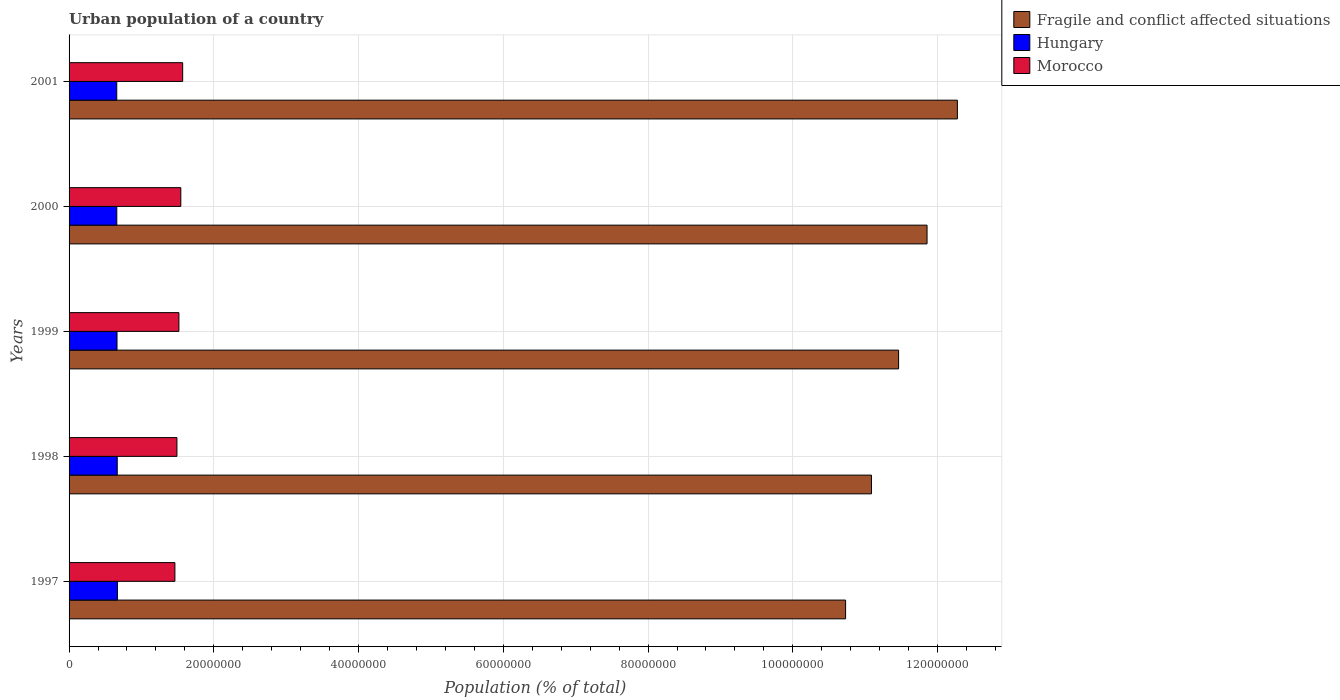How many different coloured bars are there?
Offer a terse response. 3. How many groups of bars are there?
Give a very brief answer. 5. Are the number of bars per tick equal to the number of legend labels?
Give a very brief answer. Yes. How many bars are there on the 5th tick from the top?
Ensure brevity in your answer.  3. How many bars are there on the 3rd tick from the bottom?
Your response must be concise. 3. In how many cases, is the number of bars for a given year not equal to the number of legend labels?
Ensure brevity in your answer.  0. What is the urban population in Hungary in 2000?
Your answer should be compact. 6.59e+06. Across all years, what is the maximum urban population in Fragile and conflict affected situations?
Offer a very short reply. 1.23e+08. Across all years, what is the minimum urban population in Hungary?
Make the answer very short. 6.59e+06. What is the total urban population in Hungary in the graph?
Provide a short and direct response. 3.31e+07. What is the difference between the urban population in Fragile and conflict affected situations in 1998 and that in 2000?
Offer a terse response. -7.68e+06. What is the difference between the urban population in Morocco in 1998 and the urban population in Hungary in 2001?
Offer a terse response. 8.32e+06. What is the average urban population in Morocco per year?
Provide a succinct answer. 1.52e+07. In the year 1997, what is the difference between the urban population in Morocco and urban population in Fragile and conflict affected situations?
Your answer should be compact. -9.27e+07. What is the ratio of the urban population in Morocco in 1997 to that in 1999?
Your answer should be very brief. 0.96. Is the urban population in Hungary in 1998 less than that in 1999?
Your response must be concise. No. Is the difference between the urban population in Morocco in 1999 and 2000 greater than the difference between the urban population in Fragile and conflict affected situations in 1999 and 2000?
Give a very brief answer. Yes. What is the difference between the highest and the second highest urban population in Hungary?
Keep it short and to the point. 2.86e+04. What is the difference between the highest and the lowest urban population in Morocco?
Ensure brevity in your answer.  1.07e+06. In how many years, is the urban population in Fragile and conflict affected situations greater than the average urban population in Fragile and conflict affected situations taken over all years?
Make the answer very short. 2. What does the 2nd bar from the top in 1998 represents?
Your answer should be very brief. Hungary. What does the 3rd bar from the bottom in 2001 represents?
Your answer should be very brief. Morocco. How many bars are there?
Make the answer very short. 15. Are all the bars in the graph horizontal?
Your response must be concise. Yes. Are the values on the major ticks of X-axis written in scientific E-notation?
Offer a very short reply. No. Does the graph contain any zero values?
Your answer should be very brief. No. Does the graph contain grids?
Make the answer very short. Yes. Where does the legend appear in the graph?
Make the answer very short. Top right. How many legend labels are there?
Make the answer very short. 3. What is the title of the graph?
Ensure brevity in your answer.  Urban population of a country. What is the label or title of the X-axis?
Provide a short and direct response. Population (% of total). What is the Population (% of total) of Fragile and conflict affected situations in 1997?
Make the answer very short. 1.07e+08. What is the Population (% of total) of Hungary in 1997?
Ensure brevity in your answer.  6.68e+06. What is the Population (% of total) of Morocco in 1997?
Offer a terse response. 1.46e+07. What is the Population (% of total) of Fragile and conflict affected situations in 1998?
Your response must be concise. 1.11e+08. What is the Population (% of total) of Hungary in 1998?
Give a very brief answer. 6.66e+06. What is the Population (% of total) of Morocco in 1998?
Give a very brief answer. 1.49e+07. What is the Population (% of total) of Fragile and conflict affected situations in 1999?
Offer a terse response. 1.15e+08. What is the Population (% of total) in Hungary in 1999?
Give a very brief answer. 6.62e+06. What is the Population (% of total) of Morocco in 1999?
Your answer should be compact. 1.52e+07. What is the Population (% of total) of Fragile and conflict affected situations in 2000?
Offer a terse response. 1.19e+08. What is the Population (% of total) in Hungary in 2000?
Your answer should be compact. 6.59e+06. What is the Population (% of total) in Morocco in 2000?
Your response must be concise. 1.54e+07. What is the Population (% of total) of Fragile and conflict affected situations in 2001?
Your answer should be compact. 1.23e+08. What is the Population (% of total) of Hungary in 2001?
Keep it short and to the point. 6.59e+06. What is the Population (% of total) of Morocco in 2001?
Provide a succinct answer. 1.57e+07. Across all years, what is the maximum Population (% of total) in Fragile and conflict affected situations?
Offer a very short reply. 1.23e+08. Across all years, what is the maximum Population (% of total) of Hungary?
Ensure brevity in your answer.  6.68e+06. Across all years, what is the maximum Population (% of total) in Morocco?
Offer a terse response. 1.57e+07. Across all years, what is the minimum Population (% of total) in Fragile and conflict affected situations?
Give a very brief answer. 1.07e+08. Across all years, what is the minimum Population (% of total) in Hungary?
Your answer should be very brief. 6.59e+06. Across all years, what is the minimum Population (% of total) in Morocco?
Provide a short and direct response. 1.46e+07. What is the total Population (% of total) of Fragile and conflict affected situations in the graph?
Provide a short and direct response. 5.74e+08. What is the total Population (% of total) of Hungary in the graph?
Offer a terse response. 3.31e+07. What is the total Population (% of total) of Morocco in the graph?
Your answer should be very brief. 7.58e+07. What is the difference between the Population (% of total) of Fragile and conflict affected situations in 1997 and that in 1998?
Your answer should be compact. -3.58e+06. What is the difference between the Population (% of total) of Hungary in 1997 and that in 1998?
Offer a very short reply. 2.86e+04. What is the difference between the Population (% of total) in Morocco in 1997 and that in 1998?
Keep it short and to the point. -2.80e+05. What is the difference between the Population (% of total) of Fragile and conflict affected situations in 1997 and that in 1999?
Offer a terse response. -7.32e+06. What is the difference between the Population (% of total) of Hungary in 1997 and that in 1999?
Give a very brief answer. 6.04e+04. What is the difference between the Population (% of total) in Morocco in 1997 and that in 1999?
Ensure brevity in your answer.  -5.53e+05. What is the difference between the Population (% of total) of Fragile and conflict affected situations in 1997 and that in 2000?
Offer a very short reply. -1.13e+07. What is the difference between the Population (% of total) of Hungary in 1997 and that in 2000?
Provide a succinct answer. 9.06e+04. What is the difference between the Population (% of total) in Morocco in 1997 and that in 2000?
Make the answer very short. -8.17e+05. What is the difference between the Population (% of total) of Fragile and conflict affected situations in 1997 and that in 2001?
Your answer should be very brief. -1.54e+07. What is the difference between the Population (% of total) of Hungary in 1997 and that in 2001?
Provide a short and direct response. 9.60e+04. What is the difference between the Population (% of total) of Morocco in 1997 and that in 2001?
Keep it short and to the point. -1.07e+06. What is the difference between the Population (% of total) in Fragile and conflict affected situations in 1998 and that in 1999?
Ensure brevity in your answer.  -3.75e+06. What is the difference between the Population (% of total) of Hungary in 1998 and that in 1999?
Offer a very short reply. 3.18e+04. What is the difference between the Population (% of total) in Morocco in 1998 and that in 1999?
Offer a very short reply. -2.73e+05. What is the difference between the Population (% of total) in Fragile and conflict affected situations in 1998 and that in 2000?
Give a very brief answer. -7.68e+06. What is the difference between the Population (% of total) of Hungary in 1998 and that in 2000?
Offer a very short reply. 6.20e+04. What is the difference between the Population (% of total) in Morocco in 1998 and that in 2000?
Make the answer very short. -5.37e+05. What is the difference between the Population (% of total) of Fragile and conflict affected situations in 1998 and that in 2001?
Ensure brevity in your answer.  -1.19e+07. What is the difference between the Population (% of total) in Hungary in 1998 and that in 2001?
Your response must be concise. 6.74e+04. What is the difference between the Population (% of total) of Morocco in 1998 and that in 2001?
Offer a very short reply. -7.93e+05. What is the difference between the Population (% of total) of Fragile and conflict affected situations in 1999 and that in 2000?
Your answer should be very brief. -3.93e+06. What is the difference between the Population (% of total) in Hungary in 1999 and that in 2000?
Your answer should be compact. 3.02e+04. What is the difference between the Population (% of total) of Morocco in 1999 and that in 2000?
Ensure brevity in your answer.  -2.64e+05. What is the difference between the Population (% of total) of Fragile and conflict affected situations in 1999 and that in 2001?
Provide a succinct answer. -8.12e+06. What is the difference between the Population (% of total) of Hungary in 1999 and that in 2001?
Offer a terse response. 3.56e+04. What is the difference between the Population (% of total) of Morocco in 1999 and that in 2001?
Ensure brevity in your answer.  -5.20e+05. What is the difference between the Population (% of total) of Fragile and conflict affected situations in 2000 and that in 2001?
Your answer should be compact. -4.19e+06. What is the difference between the Population (% of total) in Hungary in 2000 and that in 2001?
Offer a terse response. 5430. What is the difference between the Population (% of total) of Morocco in 2000 and that in 2001?
Offer a terse response. -2.56e+05. What is the difference between the Population (% of total) of Fragile and conflict affected situations in 1997 and the Population (% of total) of Hungary in 1998?
Ensure brevity in your answer.  1.01e+08. What is the difference between the Population (% of total) in Fragile and conflict affected situations in 1997 and the Population (% of total) in Morocco in 1998?
Provide a short and direct response. 9.24e+07. What is the difference between the Population (% of total) of Hungary in 1997 and the Population (% of total) of Morocco in 1998?
Provide a short and direct response. -8.22e+06. What is the difference between the Population (% of total) in Fragile and conflict affected situations in 1997 and the Population (% of total) in Hungary in 1999?
Provide a short and direct response. 1.01e+08. What is the difference between the Population (% of total) of Fragile and conflict affected situations in 1997 and the Population (% of total) of Morocco in 1999?
Offer a terse response. 9.21e+07. What is the difference between the Population (% of total) in Hungary in 1997 and the Population (% of total) in Morocco in 1999?
Offer a terse response. -8.49e+06. What is the difference between the Population (% of total) in Fragile and conflict affected situations in 1997 and the Population (% of total) in Hungary in 2000?
Your answer should be compact. 1.01e+08. What is the difference between the Population (% of total) of Fragile and conflict affected situations in 1997 and the Population (% of total) of Morocco in 2000?
Make the answer very short. 9.19e+07. What is the difference between the Population (% of total) of Hungary in 1997 and the Population (% of total) of Morocco in 2000?
Give a very brief answer. -8.76e+06. What is the difference between the Population (% of total) of Fragile and conflict affected situations in 1997 and the Population (% of total) of Hungary in 2001?
Keep it short and to the point. 1.01e+08. What is the difference between the Population (% of total) of Fragile and conflict affected situations in 1997 and the Population (% of total) of Morocco in 2001?
Provide a short and direct response. 9.16e+07. What is the difference between the Population (% of total) of Hungary in 1997 and the Population (% of total) of Morocco in 2001?
Give a very brief answer. -9.01e+06. What is the difference between the Population (% of total) in Fragile and conflict affected situations in 1998 and the Population (% of total) in Hungary in 1999?
Provide a succinct answer. 1.04e+08. What is the difference between the Population (% of total) of Fragile and conflict affected situations in 1998 and the Population (% of total) of Morocco in 1999?
Offer a very short reply. 9.57e+07. What is the difference between the Population (% of total) of Hungary in 1998 and the Population (% of total) of Morocco in 1999?
Offer a very short reply. -8.52e+06. What is the difference between the Population (% of total) in Fragile and conflict affected situations in 1998 and the Population (% of total) in Hungary in 2000?
Provide a succinct answer. 1.04e+08. What is the difference between the Population (% of total) in Fragile and conflict affected situations in 1998 and the Population (% of total) in Morocco in 2000?
Make the answer very short. 9.54e+07. What is the difference between the Population (% of total) of Hungary in 1998 and the Population (% of total) of Morocco in 2000?
Ensure brevity in your answer.  -8.79e+06. What is the difference between the Population (% of total) in Fragile and conflict affected situations in 1998 and the Population (% of total) in Hungary in 2001?
Keep it short and to the point. 1.04e+08. What is the difference between the Population (% of total) in Fragile and conflict affected situations in 1998 and the Population (% of total) in Morocco in 2001?
Provide a short and direct response. 9.52e+07. What is the difference between the Population (% of total) of Hungary in 1998 and the Population (% of total) of Morocco in 2001?
Offer a terse response. -9.04e+06. What is the difference between the Population (% of total) in Fragile and conflict affected situations in 1999 and the Population (% of total) in Hungary in 2000?
Keep it short and to the point. 1.08e+08. What is the difference between the Population (% of total) in Fragile and conflict affected situations in 1999 and the Population (% of total) in Morocco in 2000?
Offer a terse response. 9.92e+07. What is the difference between the Population (% of total) of Hungary in 1999 and the Population (% of total) of Morocco in 2000?
Ensure brevity in your answer.  -8.82e+06. What is the difference between the Population (% of total) of Fragile and conflict affected situations in 1999 and the Population (% of total) of Hungary in 2001?
Offer a terse response. 1.08e+08. What is the difference between the Population (% of total) in Fragile and conflict affected situations in 1999 and the Population (% of total) in Morocco in 2001?
Your answer should be compact. 9.89e+07. What is the difference between the Population (% of total) of Hungary in 1999 and the Population (% of total) of Morocco in 2001?
Ensure brevity in your answer.  -9.07e+06. What is the difference between the Population (% of total) in Fragile and conflict affected situations in 2000 and the Population (% of total) in Hungary in 2001?
Offer a terse response. 1.12e+08. What is the difference between the Population (% of total) of Fragile and conflict affected situations in 2000 and the Population (% of total) of Morocco in 2001?
Ensure brevity in your answer.  1.03e+08. What is the difference between the Population (% of total) of Hungary in 2000 and the Population (% of total) of Morocco in 2001?
Keep it short and to the point. -9.10e+06. What is the average Population (% of total) in Fragile and conflict affected situations per year?
Ensure brevity in your answer.  1.15e+08. What is the average Population (% of total) in Hungary per year?
Keep it short and to the point. 6.63e+06. What is the average Population (% of total) in Morocco per year?
Offer a very short reply. 1.52e+07. In the year 1997, what is the difference between the Population (% of total) of Fragile and conflict affected situations and Population (% of total) of Hungary?
Your response must be concise. 1.01e+08. In the year 1997, what is the difference between the Population (% of total) in Fragile and conflict affected situations and Population (% of total) in Morocco?
Provide a short and direct response. 9.27e+07. In the year 1997, what is the difference between the Population (% of total) of Hungary and Population (% of total) of Morocco?
Offer a very short reply. -7.94e+06. In the year 1998, what is the difference between the Population (% of total) in Fragile and conflict affected situations and Population (% of total) in Hungary?
Your answer should be compact. 1.04e+08. In the year 1998, what is the difference between the Population (% of total) of Fragile and conflict affected situations and Population (% of total) of Morocco?
Offer a terse response. 9.60e+07. In the year 1998, what is the difference between the Population (% of total) in Hungary and Population (% of total) in Morocco?
Ensure brevity in your answer.  -8.25e+06. In the year 1999, what is the difference between the Population (% of total) of Fragile and conflict affected situations and Population (% of total) of Hungary?
Offer a terse response. 1.08e+08. In the year 1999, what is the difference between the Population (% of total) of Fragile and conflict affected situations and Population (% of total) of Morocco?
Offer a terse response. 9.94e+07. In the year 1999, what is the difference between the Population (% of total) in Hungary and Population (% of total) in Morocco?
Offer a very short reply. -8.55e+06. In the year 2000, what is the difference between the Population (% of total) in Fragile and conflict affected situations and Population (% of total) in Hungary?
Offer a terse response. 1.12e+08. In the year 2000, what is the difference between the Population (% of total) in Fragile and conflict affected situations and Population (% of total) in Morocco?
Keep it short and to the point. 1.03e+08. In the year 2000, what is the difference between the Population (% of total) in Hungary and Population (% of total) in Morocco?
Provide a succinct answer. -8.85e+06. In the year 2001, what is the difference between the Population (% of total) in Fragile and conflict affected situations and Population (% of total) in Hungary?
Your response must be concise. 1.16e+08. In the year 2001, what is the difference between the Population (% of total) of Fragile and conflict affected situations and Population (% of total) of Morocco?
Offer a terse response. 1.07e+08. In the year 2001, what is the difference between the Population (% of total) of Hungary and Population (% of total) of Morocco?
Your response must be concise. -9.11e+06. What is the ratio of the Population (% of total) of Fragile and conflict affected situations in 1997 to that in 1998?
Give a very brief answer. 0.97. What is the ratio of the Population (% of total) of Morocco in 1997 to that in 1998?
Offer a very short reply. 0.98. What is the ratio of the Population (% of total) of Fragile and conflict affected situations in 1997 to that in 1999?
Offer a terse response. 0.94. What is the ratio of the Population (% of total) in Hungary in 1997 to that in 1999?
Your response must be concise. 1.01. What is the ratio of the Population (% of total) of Morocco in 1997 to that in 1999?
Your response must be concise. 0.96. What is the ratio of the Population (% of total) of Fragile and conflict affected situations in 1997 to that in 2000?
Keep it short and to the point. 0.91. What is the ratio of the Population (% of total) in Hungary in 1997 to that in 2000?
Keep it short and to the point. 1.01. What is the ratio of the Population (% of total) of Morocco in 1997 to that in 2000?
Give a very brief answer. 0.95. What is the ratio of the Population (% of total) in Fragile and conflict affected situations in 1997 to that in 2001?
Your response must be concise. 0.87. What is the ratio of the Population (% of total) of Hungary in 1997 to that in 2001?
Keep it short and to the point. 1.01. What is the ratio of the Population (% of total) of Morocco in 1997 to that in 2001?
Keep it short and to the point. 0.93. What is the ratio of the Population (% of total) in Fragile and conflict affected situations in 1998 to that in 1999?
Give a very brief answer. 0.97. What is the ratio of the Population (% of total) in Fragile and conflict affected situations in 1998 to that in 2000?
Keep it short and to the point. 0.94. What is the ratio of the Population (% of total) of Hungary in 1998 to that in 2000?
Your answer should be compact. 1.01. What is the ratio of the Population (% of total) in Morocco in 1998 to that in 2000?
Offer a very short reply. 0.97. What is the ratio of the Population (% of total) of Fragile and conflict affected situations in 1998 to that in 2001?
Your answer should be very brief. 0.9. What is the ratio of the Population (% of total) in Hungary in 1998 to that in 2001?
Offer a terse response. 1.01. What is the ratio of the Population (% of total) in Morocco in 1998 to that in 2001?
Provide a succinct answer. 0.95. What is the ratio of the Population (% of total) of Fragile and conflict affected situations in 1999 to that in 2000?
Offer a very short reply. 0.97. What is the ratio of the Population (% of total) of Morocco in 1999 to that in 2000?
Offer a terse response. 0.98. What is the ratio of the Population (% of total) of Fragile and conflict affected situations in 1999 to that in 2001?
Make the answer very short. 0.93. What is the ratio of the Population (% of total) in Hungary in 1999 to that in 2001?
Ensure brevity in your answer.  1.01. What is the ratio of the Population (% of total) of Morocco in 1999 to that in 2001?
Your answer should be compact. 0.97. What is the ratio of the Population (% of total) of Fragile and conflict affected situations in 2000 to that in 2001?
Give a very brief answer. 0.97. What is the ratio of the Population (% of total) in Hungary in 2000 to that in 2001?
Offer a very short reply. 1. What is the ratio of the Population (% of total) of Morocco in 2000 to that in 2001?
Your response must be concise. 0.98. What is the difference between the highest and the second highest Population (% of total) of Fragile and conflict affected situations?
Your response must be concise. 4.19e+06. What is the difference between the highest and the second highest Population (% of total) of Hungary?
Your response must be concise. 2.86e+04. What is the difference between the highest and the second highest Population (% of total) in Morocco?
Offer a terse response. 2.56e+05. What is the difference between the highest and the lowest Population (% of total) in Fragile and conflict affected situations?
Provide a succinct answer. 1.54e+07. What is the difference between the highest and the lowest Population (% of total) of Hungary?
Provide a succinct answer. 9.60e+04. What is the difference between the highest and the lowest Population (% of total) of Morocco?
Give a very brief answer. 1.07e+06. 